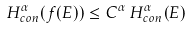Convert formula to latex. <formula><loc_0><loc_0><loc_500><loc_500>H ^ { \alpha } _ { c o n } ( f ( E ) ) \leq C ^ { \alpha } \, H ^ { \alpha } _ { c o n } ( E )</formula> 